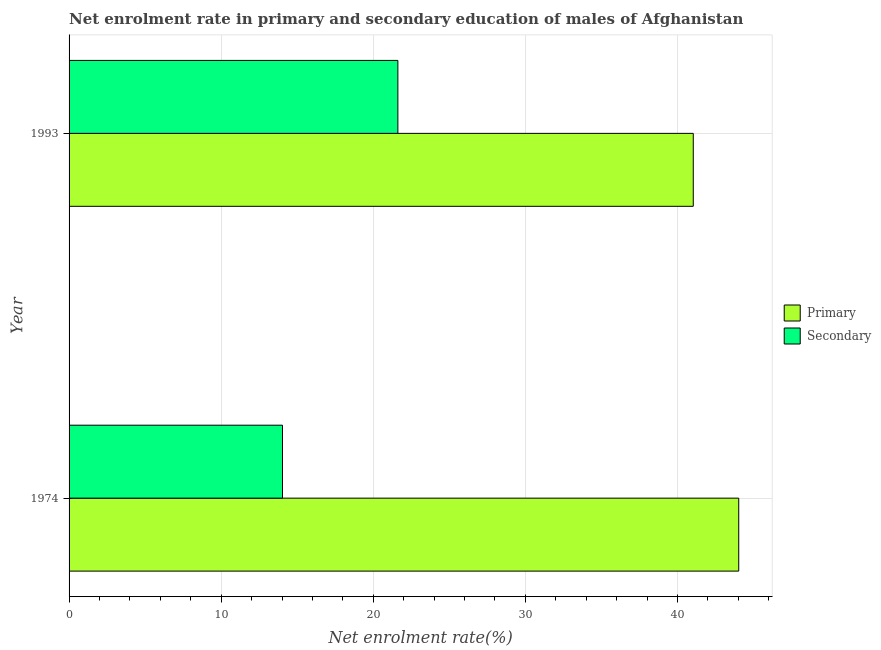How many bars are there on the 1st tick from the top?
Provide a succinct answer. 2. What is the label of the 1st group of bars from the top?
Your response must be concise. 1993. In how many cases, is the number of bars for a given year not equal to the number of legend labels?
Your answer should be compact. 0. What is the enrollment rate in primary education in 1993?
Your answer should be compact. 41.04. Across all years, what is the maximum enrollment rate in primary education?
Provide a succinct answer. 44.03. Across all years, what is the minimum enrollment rate in secondary education?
Keep it short and to the point. 14.03. In which year was the enrollment rate in secondary education maximum?
Make the answer very short. 1993. In which year was the enrollment rate in primary education minimum?
Your response must be concise. 1993. What is the total enrollment rate in primary education in the graph?
Provide a succinct answer. 85.07. What is the difference between the enrollment rate in primary education in 1974 and that in 1993?
Offer a very short reply. 2.99. What is the difference between the enrollment rate in primary education in 1974 and the enrollment rate in secondary education in 1993?
Ensure brevity in your answer.  22.41. What is the average enrollment rate in secondary education per year?
Offer a terse response. 17.82. In the year 1993, what is the difference between the enrollment rate in primary education and enrollment rate in secondary education?
Ensure brevity in your answer.  19.42. What is the ratio of the enrollment rate in secondary education in 1974 to that in 1993?
Give a very brief answer. 0.65. In how many years, is the enrollment rate in secondary education greater than the average enrollment rate in secondary education taken over all years?
Give a very brief answer. 1. What does the 1st bar from the top in 1974 represents?
Keep it short and to the point. Secondary. What does the 1st bar from the bottom in 1974 represents?
Keep it short and to the point. Primary. How many years are there in the graph?
Provide a succinct answer. 2. Are the values on the major ticks of X-axis written in scientific E-notation?
Provide a short and direct response. No. Does the graph contain any zero values?
Provide a short and direct response. No. Where does the legend appear in the graph?
Your answer should be very brief. Center right. How many legend labels are there?
Your answer should be compact. 2. What is the title of the graph?
Your answer should be compact. Net enrolment rate in primary and secondary education of males of Afghanistan. What is the label or title of the X-axis?
Provide a short and direct response. Net enrolment rate(%). What is the label or title of the Y-axis?
Your answer should be compact. Year. What is the Net enrolment rate(%) in Primary in 1974?
Your answer should be compact. 44.03. What is the Net enrolment rate(%) of Secondary in 1974?
Give a very brief answer. 14.03. What is the Net enrolment rate(%) of Primary in 1993?
Offer a very short reply. 41.04. What is the Net enrolment rate(%) in Secondary in 1993?
Your answer should be compact. 21.62. Across all years, what is the maximum Net enrolment rate(%) of Primary?
Ensure brevity in your answer.  44.03. Across all years, what is the maximum Net enrolment rate(%) of Secondary?
Ensure brevity in your answer.  21.62. Across all years, what is the minimum Net enrolment rate(%) in Primary?
Provide a short and direct response. 41.04. Across all years, what is the minimum Net enrolment rate(%) in Secondary?
Provide a succinct answer. 14.03. What is the total Net enrolment rate(%) of Primary in the graph?
Provide a short and direct response. 85.07. What is the total Net enrolment rate(%) of Secondary in the graph?
Your response must be concise. 35.65. What is the difference between the Net enrolment rate(%) of Primary in 1974 and that in 1993?
Your answer should be very brief. 2.99. What is the difference between the Net enrolment rate(%) of Secondary in 1974 and that in 1993?
Offer a terse response. -7.59. What is the difference between the Net enrolment rate(%) of Primary in 1974 and the Net enrolment rate(%) of Secondary in 1993?
Offer a very short reply. 22.41. What is the average Net enrolment rate(%) of Primary per year?
Make the answer very short. 42.53. What is the average Net enrolment rate(%) in Secondary per year?
Offer a terse response. 17.83. In the year 1974, what is the difference between the Net enrolment rate(%) in Primary and Net enrolment rate(%) in Secondary?
Provide a short and direct response. 30. In the year 1993, what is the difference between the Net enrolment rate(%) of Primary and Net enrolment rate(%) of Secondary?
Your answer should be very brief. 19.42. What is the ratio of the Net enrolment rate(%) in Primary in 1974 to that in 1993?
Keep it short and to the point. 1.07. What is the ratio of the Net enrolment rate(%) in Secondary in 1974 to that in 1993?
Keep it short and to the point. 0.65. What is the difference between the highest and the second highest Net enrolment rate(%) of Primary?
Offer a terse response. 2.99. What is the difference between the highest and the second highest Net enrolment rate(%) of Secondary?
Your answer should be very brief. 7.59. What is the difference between the highest and the lowest Net enrolment rate(%) of Primary?
Ensure brevity in your answer.  2.99. What is the difference between the highest and the lowest Net enrolment rate(%) of Secondary?
Make the answer very short. 7.59. 